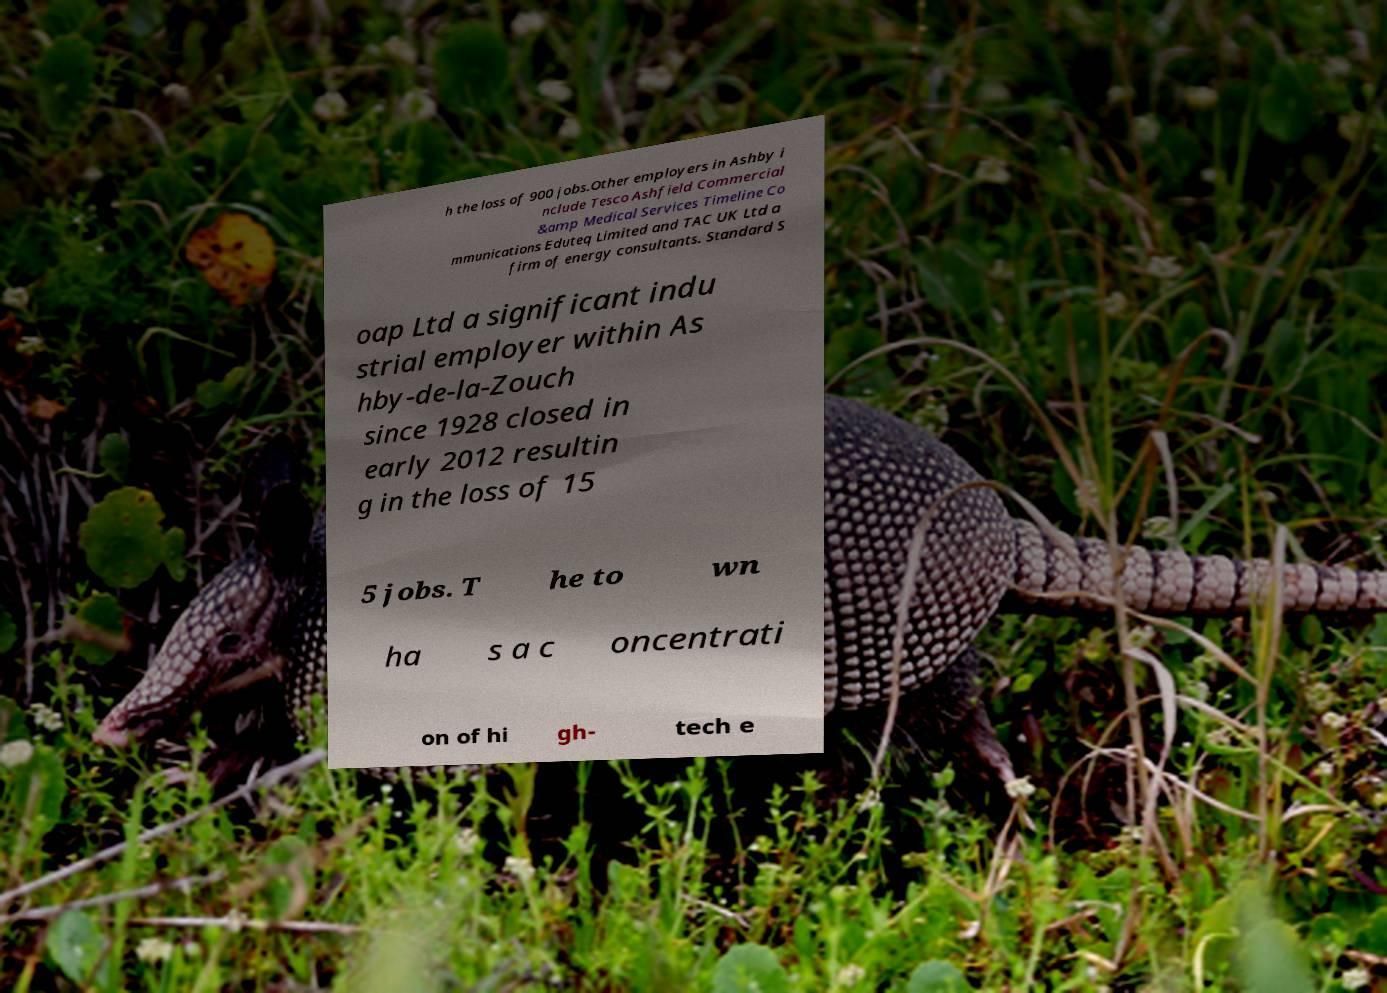Can you accurately transcribe the text from the provided image for me? h the loss of 900 jobs.Other employers in Ashby i nclude Tesco Ashfield Commercial &amp Medical Services Timeline Co mmunications Eduteq Limited and TAC UK Ltd a firm of energy consultants. Standard S oap Ltd a significant indu strial employer within As hby-de-la-Zouch since 1928 closed in early 2012 resultin g in the loss of 15 5 jobs. T he to wn ha s a c oncentrati on of hi gh- tech e 